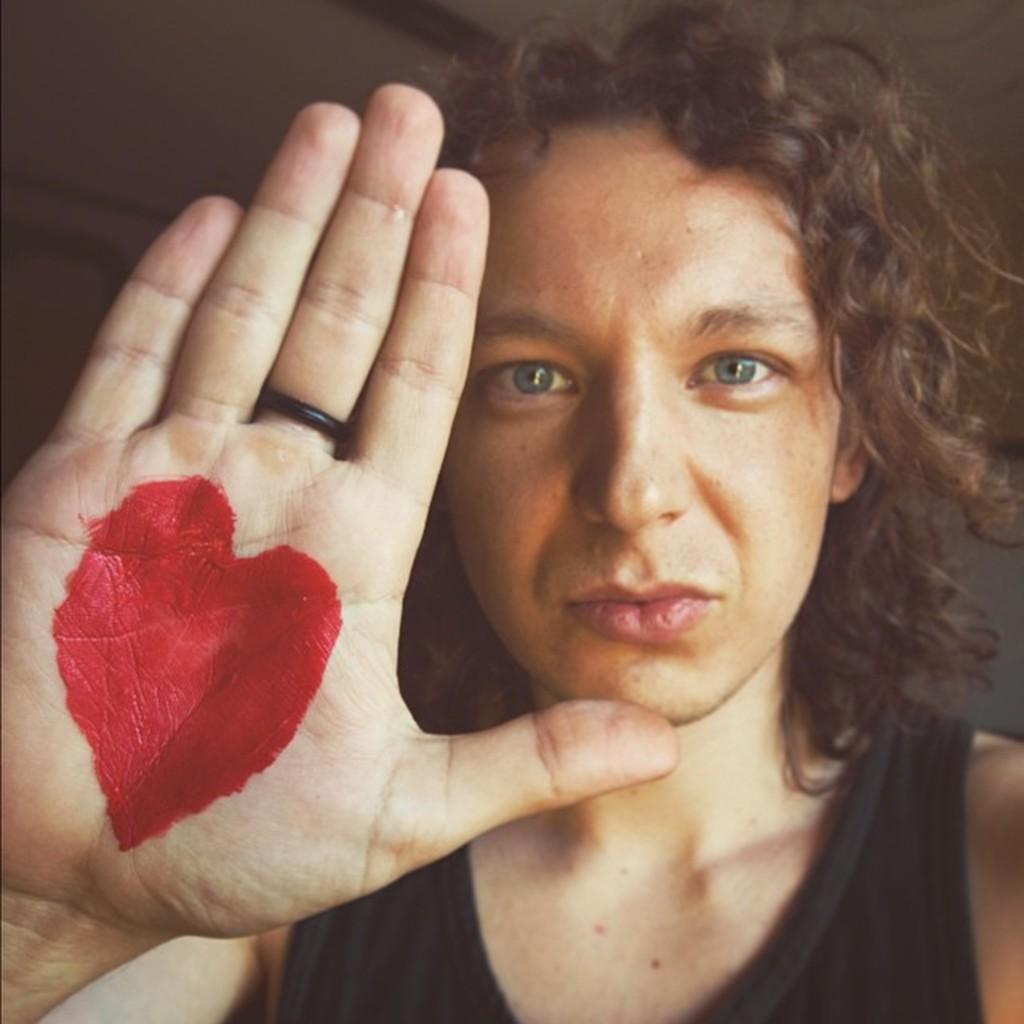What is the position of the woman in the image? There is a woman seated in the image. Can you describe any notable detail about the woman's hand? The woman's hand has red color on the palm. What theory does the woman have about the red color on her toes in the image? There is no mention of the woman's toes in the image, and therefore no theory about them can be discussed. 